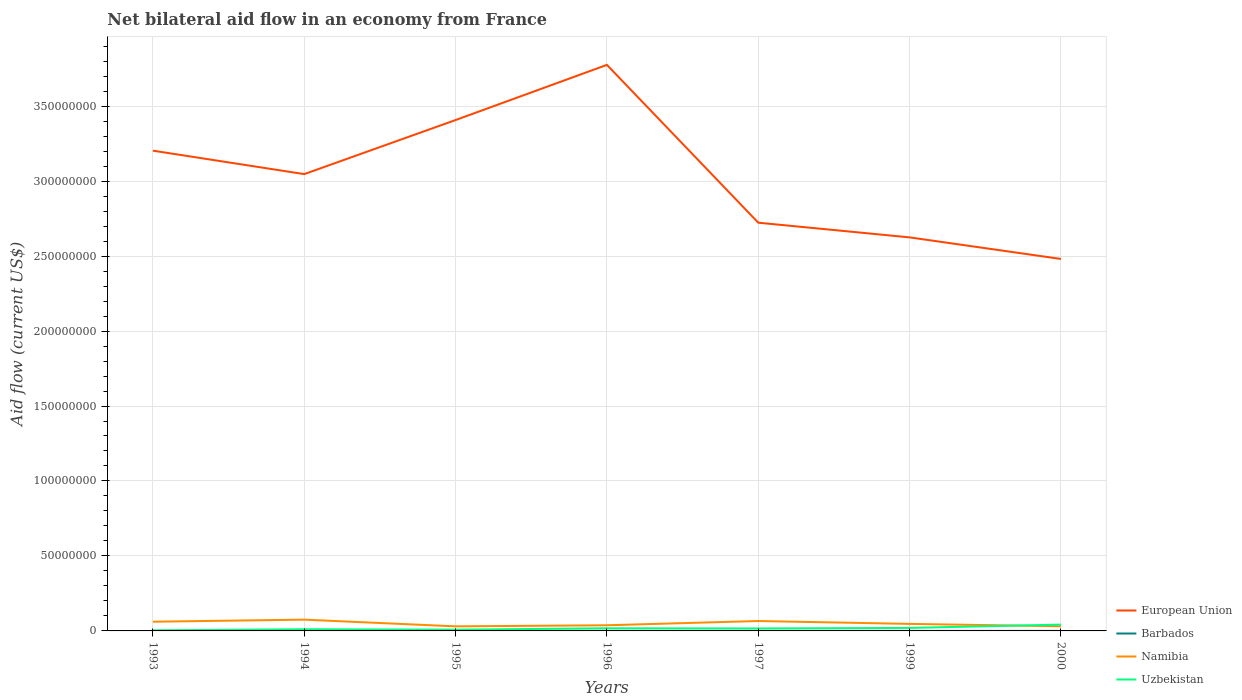How many different coloured lines are there?
Offer a very short reply. 4. Is the number of lines equal to the number of legend labels?
Provide a succinct answer. Yes. Across all years, what is the maximum net bilateral aid flow in Uzbekistan?
Offer a very short reply. 3.80e+05. What is the total net bilateral aid flow in Uzbekistan in the graph?
Offer a very short reply. -2.21e+06. What is the difference between the highest and the second highest net bilateral aid flow in Uzbekistan?
Offer a terse response. 3.83e+06. What is the difference between the highest and the lowest net bilateral aid flow in European Union?
Your answer should be very brief. 4. What is the difference between two consecutive major ticks on the Y-axis?
Your answer should be very brief. 5.00e+07. Are the values on the major ticks of Y-axis written in scientific E-notation?
Keep it short and to the point. No. Does the graph contain any zero values?
Your answer should be compact. No. Where does the legend appear in the graph?
Offer a terse response. Bottom right. What is the title of the graph?
Offer a very short reply. Net bilateral aid flow in an economy from France. Does "Korea (Democratic)" appear as one of the legend labels in the graph?
Your answer should be very brief. No. What is the label or title of the Y-axis?
Ensure brevity in your answer.  Aid flow (current US$). What is the Aid flow (current US$) of European Union in 1993?
Provide a short and direct response. 3.20e+08. What is the Aid flow (current US$) in Namibia in 1993?
Your response must be concise. 6.15e+06. What is the Aid flow (current US$) in Uzbekistan in 1993?
Provide a succinct answer. 3.80e+05. What is the Aid flow (current US$) in European Union in 1994?
Ensure brevity in your answer.  3.05e+08. What is the Aid flow (current US$) of Namibia in 1994?
Your response must be concise. 7.52e+06. What is the Aid flow (current US$) of Uzbekistan in 1994?
Keep it short and to the point. 1.11e+06. What is the Aid flow (current US$) in European Union in 1995?
Ensure brevity in your answer.  3.41e+08. What is the Aid flow (current US$) in Barbados in 1995?
Offer a very short reply. 3.00e+04. What is the Aid flow (current US$) in Namibia in 1995?
Provide a short and direct response. 3.04e+06. What is the Aid flow (current US$) of Uzbekistan in 1995?
Your response must be concise. 8.30e+05. What is the Aid flow (current US$) of European Union in 1996?
Provide a short and direct response. 3.78e+08. What is the Aid flow (current US$) of Namibia in 1996?
Give a very brief answer. 3.77e+06. What is the Aid flow (current US$) in Uzbekistan in 1996?
Give a very brief answer. 1.75e+06. What is the Aid flow (current US$) in European Union in 1997?
Make the answer very short. 2.72e+08. What is the Aid flow (current US$) of Namibia in 1997?
Keep it short and to the point. 6.61e+06. What is the Aid flow (current US$) of Uzbekistan in 1997?
Your response must be concise. 1.64e+06. What is the Aid flow (current US$) in European Union in 1999?
Provide a succinct answer. 2.62e+08. What is the Aid flow (current US$) of Namibia in 1999?
Offer a very short reply. 4.69e+06. What is the Aid flow (current US$) of European Union in 2000?
Your answer should be very brief. 2.48e+08. What is the Aid flow (current US$) of Barbados in 2000?
Keep it short and to the point. 10000. What is the Aid flow (current US$) of Namibia in 2000?
Ensure brevity in your answer.  3.12e+06. What is the Aid flow (current US$) of Uzbekistan in 2000?
Your response must be concise. 4.21e+06. Across all years, what is the maximum Aid flow (current US$) in European Union?
Provide a short and direct response. 3.78e+08. Across all years, what is the maximum Aid flow (current US$) in Barbados?
Keep it short and to the point. 5.00e+04. Across all years, what is the maximum Aid flow (current US$) in Namibia?
Offer a terse response. 7.52e+06. Across all years, what is the maximum Aid flow (current US$) of Uzbekistan?
Offer a terse response. 4.21e+06. Across all years, what is the minimum Aid flow (current US$) of European Union?
Offer a very short reply. 2.48e+08. Across all years, what is the minimum Aid flow (current US$) of Namibia?
Give a very brief answer. 3.04e+06. What is the total Aid flow (current US$) of European Union in the graph?
Keep it short and to the point. 2.13e+09. What is the total Aid flow (current US$) in Barbados in the graph?
Provide a succinct answer. 2.00e+05. What is the total Aid flow (current US$) of Namibia in the graph?
Offer a very short reply. 3.49e+07. What is the total Aid flow (current US$) in Uzbekistan in the graph?
Give a very brief answer. 1.19e+07. What is the difference between the Aid flow (current US$) in European Union in 1993 and that in 1994?
Offer a terse response. 1.56e+07. What is the difference between the Aid flow (current US$) in Namibia in 1993 and that in 1994?
Make the answer very short. -1.37e+06. What is the difference between the Aid flow (current US$) of Uzbekistan in 1993 and that in 1994?
Your answer should be compact. -7.30e+05. What is the difference between the Aid flow (current US$) in European Union in 1993 and that in 1995?
Your answer should be compact. -2.04e+07. What is the difference between the Aid flow (current US$) in Barbados in 1993 and that in 1995?
Make the answer very short. -2.00e+04. What is the difference between the Aid flow (current US$) in Namibia in 1993 and that in 1995?
Offer a very short reply. 3.11e+06. What is the difference between the Aid flow (current US$) of Uzbekistan in 1993 and that in 1995?
Give a very brief answer. -4.50e+05. What is the difference between the Aid flow (current US$) in European Union in 1993 and that in 1996?
Provide a short and direct response. -5.72e+07. What is the difference between the Aid flow (current US$) of Namibia in 1993 and that in 1996?
Ensure brevity in your answer.  2.38e+06. What is the difference between the Aid flow (current US$) in Uzbekistan in 1993 and that in 1996?
Ensure brevity in your answer.  -1.37e+06. What is the difference between the Aid flow (current US$) in European Union in 1993 and that in 1997?
Your response must be concise. 4.80e+07. What is the difference between the Aid flow (current US$) in Barbados in 1993 and that in 1997?
Provide a succinct answer. -3.00e+04. What is the difference between the Aid flow (current US$) of Namibia in 1993 and that in 1997?
Your answer should be very brief. -4.60e+05. What is the difference between the Aid flow (current US$) of Uzbekistan in 1993 and that in 1997?
Provide a short and direct response. -1.26e+06. What is the difference between the Aid flow (current US$) in European Union in 1993 and that in 1999?
Offer a very short reply. 5.78e+07. What is the difference between the Aid flow (current US$) in Namibia in 1993 and that in 1999?
Provide a short and direct response. 1.46e+06. What is the difference between the Aid flow (current US$) in Uzbekistan in 1993 and that in 1999?
Your answer should be compact. -1.62e+06. What is the difference between the Aid flow (current US$) in European Union in 1993 and that in 2000?
Give a very brief answer. 7.22e+07. What is the difference between the Aid flow (current US$) in Namibia in 1993 and that in 2000?
Your response must be concise. 3.03e+06. What is the difference between the Aid flow (current US$) in Uzbekistan in 1993 and that in 2000?
Keep it short and to the point. -3.83e+06. What is the difference between the Aid flow (current US$) of European Union in 1994 and that in 1995?
Your answer should be very brief. -3.61e+07. What is the difference between the Aid flow (current US$) in Namibia in 1994 and that in 1995?
Keep it short and to the point. 4.48e+06. What is the difference between the Aid flow (current US$) in European Union in 1994 and that in 1996?
Offer a terse response. -7.28e+07. What is the difference between the Aid flow (current US$) of Barbados in 1994 and that in 1996?
Keep it short and to the point. -2.00e+04. What is the difference between the Aid flow (current US$) in Namibia in 1994 and that in 1996?
Provide a short and direct response. 3.75e+06. What is the difference between the Aid flow (current US$) in Uzbekistan in 1994 and that in 1996?
Provide a short and direct response. -6.40e+05. What is the difference between the Aid flow (current US$) of European Union in 1994 and that in 1997?
Provide a short and direct response. 3.24e+07. What is the difference between the Aid flow (current US$) of Namibia in 1994 and that in 1997?
Your answer should be compact. 9.10e+05. What is the difference between the Aid flow (current US$) of Uzbekistan in 1994 and that in 1997?
Your response must be concise. -5.30e+05. What is the difference between the Aid flow (current US$) of European Union in 1994 and that in 1999?
Make the answer very short. 4.22e+07. What is the difference between the Aid flow (current US$) in Barbados in 1994 and that in 1999?
Provide a short and direct response. 0. What is the difference between the Aid flow (current US$) of Namibia in 1994 and that in 1999?
Give a very brief answer. 2.83e+06. What is the difference between the Aid flow (current US$) of Uzbekistan in 1994 and that in 1999?
Your answer should be very brief. -8.90e+05. What is the difference between the Aid flow (current US$) in European Union in 1994 and that in 2000?
Make the answer very short. 5.66e+07. What is the difference between the Aid flow (current US$) of Namibia in 1994 and that in 2000?
Provide a succinct answer. 4.40e+06. What is the difference between the Aid flow (current US$) of Uzbekistan in 1994 and that in 2000?
Provide a succinct answer. -3.10e+06. What is the difference between the Aid flow (current US$) of European Union in 1995 and that in 1996?
Ensure brevity in your answer.  -3.68e+07. What is the difference between the Aid flow (current US$) in Namibia in 1995 and that in 1996?
Offer a terse response. -7.30e+05. What is the difference between the Aid flow (current US$) of Uzbekistan in 1995 and that in 1996?
Make the answer very short. -9.20e+05. What is the difference between the Aid flow (current US$) in European Union in 1995 and that in 1997?
Provide a succinct answer. 6.85e+07. What is the difference between the Aid flow (current US$) in Namibia in 1995 and that in 1997?
Give a very brief answer. -3.57e+06. What is the difference between the Aid flow (current US$) in Uzbekistan in 1995 and that in 1997?
Ensure brevity in your answer.  -8.10e+05. What is the difference between the Aid flow (current US$) in European Union in 1995 and that in 1999?
Your answer should be compact. 7.83e+07. What is the difference between the Aid flow (current US$) in Namibia in 1995 and that in 1999?
Your answer should be very brief. -1.65e+06. What is the difference between the Aid flow (current US$) of Uzbekistan in 1995 and that in 1999?
Provide a succinct answer. -1.17e+06. What is the difference between the Aid flow (current US$) in European Union in 1995 and that in 2000?
Offer a terse response. 9.26e+07. What is the difference between the Aid flow (current US$) in Namibia in 1995 and that in 2000?
Your answer should be very brief. -8.00e+04. What is the difference between the Aid flow (current US$) in Uzbekistan in 1995 and that in 2000?
Provide a short and direct response. -3.38e+06. What is the difference between the Aid flow (current US$) of European Union in 1996 and that in 1997?
Your response must be concise. 1.05e+08. What is the difference between the Aid flow (current US$) in Barbados in 1996 and that in 1997?
Your answer should be compact. 10000. What is the difference between the Aid flow (current US$) in Namibia in 1996 and that in 1997?
Give a very brief answer. -2.84e+06. What is the difference between the Aid flow (current US$) of Uzbekistan in 1996 and that in 1997?
Ensure brevity in your answer.  1.10e+05. What is the difference between the Aid flow (current US$) of European Union in 1996 and that in 1999?
Offer a terse response. 1.15e+08. What is the difference between the Aid flow (current US$) in Namibia in 1996 and that in 1999?
Offer a terse response. -9.20e+05. What is the difference between the Aid flow (current US$) of Uzbekistan in 1996 and that in 1999?
Keep it short and to the point. -2.50e+05. What is the difference between the Aid flow (current US$) of European Union in 1996 and that in 2000?
Keep it short and to the point. 1.29e+08. What is the difference between the Aid flow (current US$) in Barbados in 1996 and that in 2000?
Your answer should be compact. 4.00e+04. What is the difference between the Aid flow (current US$) of Namibia in 1996 and that in 2000?
Provide a succinct answer. 6.50e+05. What is the difference between the Aid flow (current US$) of Uzbekistan in 1996 and that in 2000?
Offer a very short reply. -2.46e+06. What is the difference between the Aid flow (current US$) in European Union in 1997 and that in 1999?
Keep it short and to the point. 9.80e+06. What is the difference between the Aid flow (current US$) of Barbados in 1997 and that in 1999?
Keep it short and to the point. 10000. What is the difference between the Aid flow (current US$) in Namibia in 1997 and that in 1999?
Offer a terse response. 1.92e+06. What is the difference between the Aid flow (current US$) in Uzbekistan in 1997 and that in 1999?
Your response must be concise. -3.60e+05. What is the difference between the Aid flow (current US$) in European Union in 1997 and that in 2000?
Make the answer very short. 2.42e+07. What is the difference between the Aid flow (current US$) in Barbados in 1997 and that in 2000?
Your answer should be compact. 3.00e+04. What is the difference between the Aid flow (current US$) of Namibia in 1997 and that in 2000?
Provide a short and direct response. 3.49e+06. What is the difference between the Aid flow (current US$) of Uzbekistan in 1997 and that in 2000?
Your response must be concise. -2.57e+06. What is the difference between the Aid flow (current US$) of European Union in 1999 and that in 2000?
Your answer should be compact. 1.44e+07. What is the difference between the Aid flow (current US$) in Namibia in 1999 and that in 2000?
Offer a very short reply. 1.57e+06. What is the difference between the Aid flow (current US$) of Uzbekistan in 1999 and that in 2000?
Offer a very short reply. -2.21e+06. What is the difference between the Aid flow (current US$) in European Union in 1993 and the Aid flow (current US$) in Barbados in 1994?
Provide a short and direct response. 3.20e+08. What is the difference between the Aid flow (current US$) of European Union in 1993 and the Aid flow (current US$) of Namibia in 1994?
Ensure brevity in your answer.  3.13e+08. What is the difference between the Aid flow (current US$) of European Union in 1993 and the Aid flow (current US$) of Uzbekistan in 1994?
Provide a short and direct response. 3.19e+08. What is the difference between the Aid flow (current US$) of Barbados in 1993 and the Aid flow (current US$) of Namibia in 1994?
Your response must be concise. -7.51e+06. What is the difference between the Aid flow (current US$) of Barbados in 1993 and the Aid flow (current US$) of Uzbekistan in 1994?
Keep it short and to the point. -1.10e+06. What is the difference between the Aid flow (current US$) in Namibia in 1993 and the Aid flow (current US$) in Uzbekistan in 1994?
Ensure brevity in your answer.  5.04e+06. What is the difference between the Aid flow (current US$) in European Union in 1993 and the Aid flow (current US$) in Barbados in 1995?
Ensure brevity in your answer.  3.20e+08. What is the difference between the Aid flow (current US$) in European Union in 1993 and the Aid flow (current US$) in Namibia in 1995?
Provide a short and direct response. 3.17e+08. What is the difference between the Aid flow (current US$) in European Union in 1993 and the Aid flow (current US$) in Uzbekistan in 1995?
Keep it short and to the point. 3.19e+08. What is the difference between the Aid flow (current US$) of Barbados in 1993 and the Aid flow (current US$) of Namibia in 1995?
Provide a short and direct response. -3.03e+06. What is the difference between the Aid flow (current US$) of Barbados in 1993 and the Aid flow (current US$) of Uzbekistan in 1995?
Keep it short and to the point. -8.20e+05. What is the difference between the Aid flow (current US$) of Namibia in 1993 and the Aid flow (current US$) of Uzbekistan in 1995?
Your answer should be very brief. 5.32e+06. What is the difference between the Aid flow (current US$) in European Union in 1993 and the Aid flow (current US$) in Barbados in 1996?
Keep it short and to the point. 3.20e+08. What is the difference between the Aid flow (current US$) of European Union in 1993 and the Aid flow (current US$) of Namibia in 1996?
Offer a very short reply. 3.17e+08. What is the difference between the Aid flow (current US$) of European Union in 1993 and the Aid flow (current US$) of Uzbekistan in 1996?
Provide a short and direct response. 3.19e+08. What is the difference between the Aid flow (current US$) in Barbados in 1993 and the Aid flow (current US$) in Namibia in 1996?
Your answer should be very brief. -3.76e+06. What is the difference between the Aid flow (current US$) of Barbados in 1993 and the Aid flow (current US$) of Uzbekistan in 1996?
Your response must be concise. -1.74e+06. What is the difference between the Aid flow (current US$) in Namibia in 1993 and the Aid flow (current US$) in Uzbekistan in 1996?
Your answer should be compact. 4.40e+06. What is the difference between the Aid flow (current US$) of European Union in 1993 and the Aid flow (current US$) of Barbados in 1997?
Your answer should be compact. 3.20e+08. What is the difference between the Aid flow (current US$) in European Union in 1993 and the Aid flow (current US$) in Namibia in 1997?
Provide a short and direct response. 3.14e+08. What is the difference between the Aid flow (current US$) of European Union in 1993 and the Aid flow (current US$) of Uzbekistan in 1997?
Keep it short and to the point. 3.19e+08. What is the difference between the Aid flow (current US$) in Barbados in 1993 and the Aid flow (current US$) in Namibia in 1997?
Your response must be concise. -6.60e+06. What is the difference between the Aid flow (current US$) of Barbados in 1993 and the Aid flow (current US$) of Uzbekistan in 1997?
Provide a succinct answer. -1.63e+06. What is the difference between the Aid flow (current US$) of Namibia in 1993 and the Aid flow (current US$) of Uzbekistan in 1997?
Ensure brevity in your answer.  4.51e+06. What is the difference between the Aid flow (current US$) of European Union in 1993 and the Aid flow (current US$) of Barbados in 1999?
Your answer should be very brief. 3.20e+08. What is the difference between the Aid flow (current US$) in European Union in 1993 and the Aid flow (current US$) in Namibia in 1999?
Provide a succinct answer. 3.16e+08. What is the difference between the Aid flow (current US$) of European Union in 1993 and the Aid flow (current US$) of Uzbekistan in 1999?
Provide a succinct answer. 3.18e+08. What is the difference between the Aid flow (current US$) of Barbados in 1993 and the Aid flow (current US$) of Namibia in 1999?
Provide a succinct answer. -4.68e+06. What is the difference between the Aid flow (current US$) in Barbados in 1993 and the Aid flow (current US$) in Uzbekistan in 1999?
Make the answer very short. -1.99e+06. What is the difference between the Aid flow (current US$) of Namibia in 1993 and the Aid flow (current US$) of Uzbekistan in 1999?
Your response must be concise. 4.15e+06. What is the difference between the Aid flow (current US$) of European Union in 1993 and the Aid flow (current US$) of Barbados in 2000?
Offer a very short reply. 3.20e+08. What is the difference between the Aid flow (current US$) of European Union in 1993 and the Aid flow (current US$) of Namibia in 2000?
Keep it short and to the point. 3.17e+08. What is the difference between the Aid flow (current US$) in European Union in 1993 and the Aid flow (current US$) in Uzbekistan in 2000?
Make the answer very short. 3.16e+08. What is the difference between the Aid flow (current US$) in Barbados in 1993 and the Aid flow (current US$) in Namibia in 2000?
Make the answer very short. -3.11e+06. What is the difference between the Aid flow (current US$) of Barbados in 1993 and the Aid flow (current US$) of Uzbekistan in 2000?
Provide a succinct answer. -4.20e+06. What is the difference between the Aid flow (current US$) in Namibia in 1993 and the Aid flow (current US$) in Uzbekistan in 2000?
Your answer should be very brief. 1.94e+06. What is the difference between the Aid flow (current US$) of European Union in 1994 and the Aid flow (current US$) of Barbados in 1995?
Offer a terse response. 3.05e+08. What is the difference between the Aid flow (current US$) in European Union in 1994 and the Aid flow (current US$) in Namibia in 1995?
Provide a succinct answer. 3.02e+08. What is the difference between the Aid flow (current US$) in European Union in 1994 and the Aid flow (current US$) in Uzbekistan in 1995?
Your answer should be compact. 3.04e+08. What is the difference between the Aid flow (current US$) of Barbados in 1994 and the Aid flow (current US$) of Namibia in 1995?
Your answer should be compact. -3.01e+06. What is the difference between the Aid flow (current US$) in Barbados in 1994 and the Aid flow (current US$) in Uzbekistan in 1995?
Your answer should be very brief. -8.00e+05. What is the difference between the Aid flow (current US$) in Namibia in 1994 and the Aid flow (current US$) in Uzbekistan in 1995?
Offer a very short reply. 6.69e+06. What is the difference between the Aid flow (current US$) of European Union in 1994 and the Aid flow (current US$) of Barbados in 1996?
Give a very brief answer. 3.05e+08. What is the difference between the Aid flow (current US$) in European Union in 1994 and the Aid flow (current US$) in Namibia in 1996?
Make the answer very short. 3.01e+08. What is the difference between the Aid flow (current US$) of European Union in 1994 and the Aid flow (current US$) of Uzbekistan in 1996?
Your answer should be very brief. 3.03e+08. What is the difference between the Aid flow (current US$) of Barbados in 1994 and the Aid flow (current US$) of Namibia in 1996?
Give a very brief answer. -3.74e+06. What is the difference between the Aid flow (current US$) in Barbados in 1994 and the Aid flow (current US$) in Uzbekistan in 1996?
Provide a succinct answer. -1.72e+06. What is the difference between the Aid flow (current US$) of Namibia in 1994 and the Aid flow (current US$) of Uzbekistan in 1996?
Provide a succinct answer. 5.77e+06. What is the difference between the Aid flow (current US$) of European Union in 1994 and the Aid flow (current US$) of Barbados in 1997?
Offer a very short reply. 3.05e+08. What is the difference between the Aid flow (current US$) of European Union in 1994 and the Aid flow (current US$) of Namibia in 1997?
Provide a succinct answer. 2.98e+08. What is the difference between the Aid flow (current US$) of European Union in 1994 and the Aid flow (current US$) of Uzbekistan in 1997?
Give a very brief answer. 3.03e+08. What is the difference between the Aid flow (current US$) of Barbados in 1994 and the Aid flow (current US$) of Namibia in 1997?
Offer a terse response. -6.58e+06. What is the difference between the Aid flow (current US$) in Barbados in 1994 and the Aid flow (current US$) in Uzbekistan in 1997?
Offer a very short reply. -1.61e+06. What is the difference between the Aid flow (current US$) in Namibia in 1994 and the Aid flow (current US$) in Uzbekistan in 1997?
Provide a succinct answer. 5.88e+06. What is the difference between the Aid flow (current US$) in European Union in 1994 and the Aid flow (current US$) in Barbados in 1999?
Keep it short and to the point. 3.05e+08. What is the difference between the Aid flow (current US$) of European Union in 1994 and the Aid flow (current US$) of Namibia in 1999?
Keep it short and to the point. 3.00e+08. What is the difference between the Aid flow (current US$) in European Union in 1994 and the Aid flow (current US$) in Uzbekistan in 1999?
Your answer should be compact. 3.03e+08. What is the difference between the Aid flow (current US$) in Barbados in 1994 and the Aid flow (current US$) in Namibia in 1999?
Ensure brevity in your answer.  -4.66e+06. What is the difference between the Aid flow (current US$) of Barbados in 1994 and the Aid flow (current US$) of Uzbekistan in 1999?
Offer a terse response. -1.97e+06. What is the difference between the Aid flow (current US$) in Namibia in 1994 and the Aid flow (current US$) in Uzbekistan in 1999?
Provide a short and direct response. 5.52e+06. What is the difference between the Aid flow (current US$) of European Union in 1994 and the Aid flow (current US$) of Barbados in 2000?
Your answer should be very brief. 3.05e+08. What is the difference between the Aid flow (current US$) of European Union in 1994 and the Aid flow (current US$) of Namibia in 2000?
Offer a terse response. 3.02e+08. What is the difference between the Aid flow (current US$) of European Union in 1994 and the Aid flow (current US$) of Uzbekistan in 2000?
Your answer should be very brief. 3.00e+08. What is the difference between the Aid flow (current US$) of Barbados in 1994 and the Aid flow (current US$) of Namibia in 2000?
Your answer should be very brief. -3.09e+06. What is the difference between the Aid flow (current US$) in Barbados in 1994 and the Aid flow (current US$) in Uzbekistan in 2000?
Your response must be concise. -4.18e+06. What is the difference between the Aid flow (current US$) in Namibia in 1994 and the Aid flow (current US$) in Uzbekistan in 2000?
Your answer should be very brief. 3.31e+06. What is the difference between the Aid flow (current US$) of European Union in 1995 and the Aid flow (current US$) of Barbados in 1996?
Make the answer very short. 3.41e+08. What is the difference between the Aid flow (current US$) of European Union in 1995 and the Aid flow (current US$) of Namibia in 1996?
Make the answer very short. 3.37e+08. What is the difference between the Aid flow (current US$) of European Union in 1995 and the Aid flow (current US$) of Uzbekistan in 1996?
Offer a very short reply. 3.39e+08. What is the difference between the Aid flow (current US$) in Barbados in 1995 and the Aid flow (current US$) in Namibia in 1996?
Keep it short and to the point. -3.74e+06. What is the difference between the Aid flow (current US$) in Barbados in 1995 and the Aid flow (current US$) in Uzbekistan in 1996?
Offer a very short reply. -1.72e+06. What is the difference between the Aid flow (current US$) of Namibia in 1995 and the Aid flow (current US$) of Uzbekistan in 1996?
Offer a terse response. 1.29e+06. What is the difference between the Aid flow (current US$) in European Union in 1995 and the Aid flow (current US$) in Barbados in 1997?
Offer a terse response. 3.41e+08. What is the difference between the Aid flow (current US$) of European Union in 1995 and the Aid flow (current US$) of Namibia in 1997?
Your response must be concise. 3.34e+08. What is the difference between the Aid flow (current US$) of European Union in 1995 and the Aid flow (current US$) of Uzbekistan in 1997?
Ensure brevity in your answer.  3.39e+08. What is the difference between the Aid flow (current US$) of Barbados in 1995 and the Aid flow (current US$) of Namibia in 1997?
Ensure brevity in your answer.  -6.58e+06. What is the difference between the Aid flow (current US$) in Barbados in 1995 and the Aid flow (current US$) in Uzbekistan in 1997?
Provide a short and direct response. -1.61e+06. What is the difference between the Aid flow (current US$) of Namibia in 1995 and the Aid flow (current US$) of Uzbekistan in 1997?
Give a very brief answer. 1.40e+06. What is the difference between the Aid flow (current US$) of European Union in 1995 and the Aid flow (current US$) of Barbados in 1999?
Make the answer very short. 3.41e+08. What is the difference between the Aid flow (current US$) in European Union in 1995 and the Aid flow (current US$) in Namibia in 1999?
Your answer should be very brief. 3.36e+08. What is the difference between the Aid flow (current US$) of European Union in 1995 and the Aid flow (current US$) of Uzbekistan in 1999?
Your response must be concise. 3.39e+08. What is the difference between the Aid flow (current US$) in Barbados in 1995 and the Aid flow (current US$) in Namibia in 1999?
Offer a terse response. -4.66e+06. What is the difference between the Aid flow (current US$) in Barbados in 1995 and the Aid flow (current US$) in Uzbekistan in 1999?
Provide a short and direct response. -1.97e+06. What is the difference between the Aid flow (current US$) of Namibia in 1995 and the Aid flow (current US$) of Uzbekistan in 1999?
Make the answer very short. 1.04e+06. What is the difference between the Aid flow (current US$) in European Union in 1995 and the Aid flow (current US$) in Barbados in 2000?
Offer a very short reply. 3.41e+08. What is the difference between the Aid flow (current US$) in European Union in 1995 and the Aid flow (current US$) in Namibia in 2000?
Ensure brevity in your answer.  3.38e+08. What is the difference between the Aid flow (current US$) in European Union in 1995 and the Aid flow (current US$) in Uzbekistan in 2000?
Ensure brevity in your answer.  3.37e+08. What is the difference between the Aid flow (current US$) in Barbados in 1995 and the Aid flow (current US$) in Namibia in 2000?
Offer a terse response. -3.09e+06. What is the difference between the Aid flow (current US$) of Barbados in 1995 and the Aid flow (current US$) of Uzbekistan in 2000?
Give a very brief answer. -4.18e+06. What is the difference between the Aid flow (current US$) in Namibia in 1995 and the Aid flow (current US$) in Uzbekistan in 2000?
Your response must be concise. -1.17e+06. What is the difference between the Aid flow (current US$) of European Union in 1996 and the Aid flow (current US$) of Barbados in 1997?
Make the answer very short. 3.77e+08. What is the difference between the Aid flow (current US$) in European Union in 1996 and the Aid flow (current US$) in Namibia in 1997?
Offer a terse response. 3.71e+08. What is the difference between the Aid flow (current US$) in European Union in 1996 and the Aid flow (current US$) in Uzbekistan in 1997?
Your response must be concise. 3.76e+08. What is the difference between the Aid flow (current US$) in Barbados in 1996 and the Aid flow (current US$) in Namibia in 1997?
Your response must be concise. -6.56e+06. What is the difference between the Aid flow (current US$) of Barbados in 1996 and the Aid flow (current US$) of Uzbekistan in 1997?
Offer a very short reply. -1.59e+06. What is the difference between the Aid flow (current US$) of Namibia in 1996 and the Aid flow (current US$) of Uzbekistan in 1997?
Make the answer very short. 2.13e+06. What is the difference between the Aid flow (current US$) in European Union in 1996 and the Aid flow (current US$) in Barbados in 1999?
Ensure brevity in your answer.  3.77e+08. What is the difference between the Aid flow (current US$) in European Union in 1996 and the Aid flow (current US$) in Namibia in 1999?
Provide a succinct answer. 3.73e+08. What is the difference between the Aid flow (current US$) of European Union in 1996 and the Aid flow (current US$) of Uzbekistan in 1999?
Your response must be concise. 3.76e+08. What is the difference between the Aid flow (current US$) of Barbados in 1996 and the Aid flow (current US$) of Namibia in 1999?
Keep it short and to the point. -4.64e+06. What is the difference between the Aid flow (current US$) of Barbados in 1996 and the Aid flow (current US$) of Uzbekistan in 1999?
Provide a short and direct response. -1.95e+06. What is the difference between the Aid flow (current US$) of Namibia in 1996 and the Aid flow (current US$) of Uzbekistan in 1999?
Offer a terse response. 1.77e+06. What is the difference between the Aid flow (current US$) in European Union in 1996 and the Aid flow (current US$) in Barbados in 2000?
Provide a short and direct response. 3.78e+08. What is the difference between the Aid flow (current US$) of European Union in 1996 and the Aid flow (current US$) of Namibia in 2000?
Your answer should be very brief. 3.74e+08. What is the difference between the Aid flow (current US$) in European Union in 1996 and the Aid flow (current US$) in Uzbekistan in 2000?
Make the answer very short. 3.73e+08. What is the difference between the Aid flow (current US$) of Barbados in 1996 and the Aid flow (current US$) of Namibia in 2000?
Make the answer very short. -3.07e+06. What is the difference between the Aid flow (current US$) of Barbados in 1996 and the Aid flow (current US$) of Uzbekistan in 2000?
Give a very brief answer. -4.16e+06. What is the difference between the Aid flow (current US$) of Namibia in 1996 and the Aid flow (current US$) of Uzbekistan in 2000?
Your response must be concise. -4.40e+05. What is the difference between the Aid flow (current US$) of European Union in 1997 and the Aid flow (current US$) of Barbados in 1999?
Your response must be concise. 2.72e+08. What is the difference between the Aid flow (current US$) in European Union in 1997 and the Aid flow (current US$) in Namibia in 1999?
Your answer should be compact. 2.68e+08. What is the difference between the Aid flow (current US$) of European Union in 1997 and the Aid flow (current US$) of Uzbekistan in 1999?
Give a very brief answer. 2.70e+08. What is the difference between the Aid flow (current US$) in Barbados in 1997 and the Aid flow (current US$) in Namibia in 1999?
Ensure brevity in your answer.  -4.65e+06. What is the difference between the Aid flow (current US$) of Barbados in 1997 and the Aid flow (current US$) of Uzbekistan in 1999?
Ensure brevity in your answer.  -1.96e+06. What is the difference between the Aid flow (current US$) of Namibia in 1997 and the Aid flow (current US$) of Uzbekistan in 1999?
Your answer should be very brief. 4.61e+06. What is the difference between the Aid flow (current US$) of European Union in 1997 and the Aid flow (current US$) of Barbados in 2000?
Give a very brief answer. 2.72e+08. What is the difference between the Aid flow (current US$) of European Union in 1997 and the Aid flow (current US$) of Namibia in 2000?
Your answer should be compact. 2.69e+08. What is the difference between the Aid flow (current US$) of European Union in 1997 and the Aid flow (current US$) of Uzbekistan in 2000?
Your answer should be very brief. 2.68e+08. What is the difference between the Aid flow (current US$) of Barbados in 1997 and the Aid flow (current US$) of Namibia in 2000?
Ensure brevity in your answer.  -3.08e+06. What is the difference between the Aid flow (current US$) of Barbados in 1997 and the Aid flow (current US$) of Uzbekistan in 2000?
Provide a short and direct response. -4.17e+06. What is the difference between the Aid flow (current US$) in Namibia in 1997 and the Aid flow (current US$) in Uzbekistan in 2000?
Your answer should be very brief. 2.40e+06. What is the difference between the Aid flow (current US$) of European Union in 1999 and the Aid flow (current US$) of Barbados in 2000?
Your answer should be very brief. 2.62e+08. What is the difference between the Aid flow (current US$) of European Union in 1999 and the Aid flow (current US$) of Namibia in 2000?
Provide a succinct answer. 2.59e+08. What is the difference between the Aid flow (current US$) of European Union in 1999 and the Aid flow (current US$) of Uzbekistan in 2000?
Your response must be concise. 2.58e+08. What is the difference between the Aid flow (current US$) of Barbados in 1999 and the Aid flow (current US$) of Namibia in 2000?
Keep it short and to the point. -3.09e+06. What is the difference between the Aid flow (current US$) in Barbados in 1999 and the Aid flow (current US$) in Uzbekistan in 2000?
Give a very brief answer. -4.18e+06. What is the difference between the Aid flow (current US$) in Namibia in 1999 and the Aid flow (current US$) in Uzbekistan in 2000?
Provide a short and direct response. 4.80e+05. What is the average Aid flow (current US$) of European Union per year?
Your answer should be compact. 3.04e+08. What is the average Aid flow (current US$) in Barbados per year?
Your response must be concise. 2.86e+04. What is the average Aid flow (current US$) in Namibia per year?
Provide a succinct answer. 4.99e+06. What is the average Aid flow (current US$) in Uzbekistan per year?
Your response must be concise. 1.70e+06. In the year 1993, what is the difference between the Aid flow (current US$) of European Union and Aid flow (current US$) of Barbados?
Your response must be concise. 3.20e+08. In the year 1993, what is the difference between the Aid flow (current US$) in European Union and Aid flow (current US$) in Namibia?
Your answer should be very brief. 3.14e+08. In the year 1993, what is the difference between the Aid flow (current US$) of European Union and Aid flow (current US$) of Uzbekistan?
Your response must be concise. 3.20e+08. In the year 1993, what is the difference between the Aid flow (current US$) in Barbados and Aid flow (current US$) in Namibia?
Your answer should be compact. -6.14e+06. In the year 1993, what is the difference between the Aid flow (current US$) in Barbados and Aid flow (current US$) in Uzbekistan?
Make the answer very short. -3.70e+05. In the year 1993, what is the difference between the Aid flow (current US$) in Namibia and Aid flow (current US$) in Uzbekistan?
Your answer should be compact. 5.77e+06. In the year 1994, what is the difference between the Aid flow (current US$) of European Union and Aid flow (current US$) of Barbados?
Give a very brief answer. 3.05e+08. In the year 1994, what is the difference between the Aid flow (current US$) of European Union and Aid flow (current US$) of Namibia?
Your answer should be very brief. 2.97e+08. In the year 1994, what is the difference between the Aid flow (current US$) in European Union and Aid flow (current US$) in Uzbekistan?
Your answer should be compact. 3.04e+08. In the year 1994, what is the difference between the Aid flow (current US$) in Barbados and Aid flow (current US$) in Namibia?
Offer a very short reply. -7.49e+06. In the year 1994, what is the difference between the Aid flow (current US$) of Barbados and Aid flow (current US$) of Uzbekistan?
Your response must be concise. -1.08e+06. In the year 1994, what is the difference between the Aid flow (current US$) of Namibia and Aid flow (current US$) of Uzbekistan?
Ensure brevity in your answer.  6.41e+06. In the year 1995, what is the difference between the Aid flow (current US$) in European Union and Aid flow (current US$) in Barbados?
Offer a terse response. 3.41e+08. In the year 1995, what is the difference between the Aid flow (current US$) in European Union and Aid flow (current US$) in Namibia?
Make the answer very short. 3.38e+08. In the year 1995, what is the difference between the Aid flow (current US$) of European Union and Aid flow (current US$) of Uzbekistan?
Your answer should be very brief. 3.40e+08. In the year 1995, what is the difference between the Aid flow (current US$) in Barbados and Aid flow (current US$) in Namibia?
Offer a very short reply. -3.01e+06. In the year 1995, what is the difference between the Aid flow (current US$) in Barbados and Aid flow (current US$) in Uzbekistan?
Offer a terse response. -8.00e+05. In the year 1995, what is the difference between the Aid flow (current US$) of Namibia and Aid flow (current US$) of Uzbekistan?
Offer a very short reply. 2.21e+06. In the year 1996, what is the difference between the Aid flow (current US$) of European Union and Aid flow (current US$) of Barbados?
Your answer should be compact. 3.77e+08. In the year 1996, what is the difference between the Aid flow (current US$) of European Union and Aid flow (current US$) of Namibia?
Provide a short and direct response. 3.74e+08. In the year 1996, what is the difference between the Aid flow (current US$) of European Union and Aid flow (current US$) of Uzbekistan?
Your response must be concise. 3.76e+08. In the year 1996, what is the difference between the Aid flow (current US$) in Barbados and Aid flow (current US$) in Namibia?
Ensure brevity in your answer.  -3.72e+06. In the year 1996, what is the difference between the Aid flow (current US$) of Barbados and Aid flow (current US$) of Uzbekistan?
Make the answer very short. -1.70e+06. In the year 1996, what is the difference between the Aid flow (current US$) in Namibia and Aid flow (current US$) in Uzbekistan?
Ensure brevity in your answer.  2.02e+06. In the year 1997, what is the difference between the Aid flow (current US$) of European Union and Aid flow (current US$) of Barbados?
Your response must be concise. 2.72e+08. In the year 1997, what is the difference between the Aid flow (current US$) in European Union and Aid flow (current US$) in Namibia?
Give a very brief answer. 2.66e+08. In the year 1997, what is the difference between the Aid flow (current US$) of European Union and Aid flow (current US$) of Uzbekistan?
Your response must be concise. 2.71e+08. In the year 1997, what is the difference between the Aid flow (current US$) in Barbados and Aid flow (current US$) in Namibia?
Provide a succinct answer. -6.57e+06. In the year 1997, what is the difference between the Aid flow (current US$) in Barbados and Aid flow (current US$) in Uzbekistan?
Your answer should be compact. -1.60e+06. In the year 1997, what is the difference between the Aid flow (current US$) in Namibia and Aid flow (current US$) in Uzbekistan?
Keep it short and to the point. 4.97e+06. In the year 1999, what is the difference between the Aid flow (current US$) of European Union and Aid flow (current US$) of Barbados?
Your answer should be very brief. 2.62e+08. In the year 1999, what is the difference between the Aid flow (current US$) in European Union and Aid flow (current US$) in Namibia?
Keep it short and to the point. 2.58e+08. In the year 1999, what is the difference between the Aid flow (current US$) of European Union and Aid flow (current US$) of Uzbekistan?
Your answer should be compact. 2.60e+08. In the year 1999, what is the difference between the Aid flow (current US$) in Barbados and Aid flow (current US$) in Namibia?
Keep it short and to the point. -4.66e+06. In the year 1999, what is the difference between the Aid flow (current US$) in Barbados and Aid flow (current US$) in Uzbekistan?
Your answer should be very brief. -1.97e+06. In the year 1999, what is the difference between the Aid flow (current US$) of Namibia and Aid flow (current US$) of Uzbekistan?
Offer a very short reply. 2.69e+06. In the year 2000, what is the difference between the Aid flow (current US$) of European Union and Aid flow (current US$) of Barbados?
Offer a very short reply. 2.48e+08. In the year 2000, what is the difference between the Aid flow (current US$) in European Union and Aid flow (current US$) in Namibia?
Keep it short and to the point. 2.45e+08. In the year 2000, what is the difference between the Aid flow (current US$) of European Union and Aid flow (current US$) of Uzbekistan?
Your answer should be compact. 2.44e+08. In the year 2000, what is the difference between the Aid flow (current US$) of Barbados and Aid flow (current US$) of Namibia?
Offer a terse response. -3.11e+06. In the year 2000, what is the difference between the Aid flow (current US$) in Barbados and Aid flow (current US$) in Uzbekistan?
Your response must be concise. -4.20e+06. In the year 2000, what is the difference between the Aid flow (current US$) of Namibia and Aid flow (current US$) of Uzbekistan?
Your answer should be compact. -1.09e+06. What is the ratio of the Aid flow (current US$) of European Union in 1993 to that in 1994?
Your answer should be compact. 1.05. What is the ratio of the Aid flow (current US$) in Barbados in 1993 to that in 1994?
Offer a terse response. 0.33. What is the ratio of the Aid flow (current US$) of Namibia in 1993 to that in 1994?
Your answer should be very brief. 0.82. What is the ratio of the Aid flow (current US$) of Uzbekistan in 1993 to that in 1994?
Ensure brevity in your answer.  0.34. What is the ratio of the Aid flow (current US$) of European Union in 1993 to that in 1995?
Give a very brief answer. 0.94. What is the ratio of the Aid flow (current US$) in Namibia in 1993 to that in 1995?
Provide a succinct answer. 2.02. What is the ratio of the Aid flow (current US$) in Uzbekistan in 1993 to that in 1995?
Offer a terse response. 0.46. What is the ratio of the Aid flow (current US$) in European Union in 1993 to that in 1996?
Offer a terse response. 0.85. What is the ratio of the Aid flow (current US$) of Barbados in 1993 to that in 1996?
Your response must be concise. 0.2. What is the ratio of the Aid flow (current US$) in Namibia in 1993 to that in 1996?
Offer a terse response. 1.63. What is the ratio of the Aid flow (current US$) in Uzbekistan in 1993 to that in 1996?
Offer a very short reply. 0.22. What is the ratio of the Aid flow (current US$) of European Union in 1993 to that in 1997?
Ensure brevity in your answer.  1.18. What is the ratio of the Aid flow (current US$) in Namibia in 1993 to that in 1997?
Offer a terse response. 0.93. What is the ratio of the Aid flow (current US$) of Uzbekistan in 1993 to that in 1997?
Your response must be concise. 0.23. What is the ratio of the Aid flow (current US$) of European Union in 1993 to that in 1999?
Your answer should be compact. 1.22. What is the ratio of the Aid flow (current US$) in Barbados in 1993 to that in 1999?
Offer a very short reply. 0.33. What is the ratio of the Aid flow (current US$) of Namibia in 1993 to that in 1999?
Your answer should be compact. 1.31. What is the ratio of the Aid flow (current US$) in Uzbekistan in 1993 to that in 1999?
Your response must be concise. 0.19. What is the ratio of the Aid flow (current US$) of European Union in 1993 to that in 2000?
Ensure brevity in your answer.  1.29. What is the ratio of the Aid flow (current US$) of Namibia in 1993 to that in 2000?
Your answer should be very brief. 1.97. What is the ratio of the Aid flow (current US$) of Uzbekistan in 1993 to that in 2000?
Your response must be concise. 0.09. What is the ratio of the Aid flow (current US$) of European Union in 1994 to that in 1995?
Make the answer very short. 0.89. What is the ratio of the Aid flow (current US$) of Namibia in 1994 to that in 1995?
Make the answer very short. 2.47. What is the ratio of the Aid flow (current US$) in Uzbekistan in 1994 to that in 1995?
Give a very brief answer. 1.34. What is the ratio of the Aid flow (current US$) in European Union in 1994 to that in 1996?
Keep it short and to the point. 0.81. What is the ratio of the Aid flow (current US$) of Namibia in 1994 to that in 1996?
Ensure brevity in your answer.  1.99. What is the ratio of the Aid flow (current US$) of Uzbekistan in 1994 to that in 1996?
Keep it short and to the point. 0.63. What is the ratio of the Aid flow (current US$) in European Union in 1994 to that in 1997?
Offer a very short reply. 1.12. What is the ratio of the Aid flow (current US$) in Barbados in 1994 to that in 1997?
Ensure brevity in your answer.  0.75. What is the ratio of the Aid flow (current US$) of Namibia in 1994 to that in 1997?
Provide a short and direct response. 1.14. What is the ratio of the Aid flow (current US$) in Uzbekistan in 1994 to that in 1997?
Ensure brevity in your answer.  0.68. What is the ratio of the Aid flow (current US$) of European Union in 1994 to that in 1999?
Offer a very short reply. 1.16. What is the ratio of the Aid flow (current US$) in Barbados in 1994 to that in 1999?
Your answer should be very brief. 1. What is the ratio of the Aid flow (current US$) of Namibia in 1994 to that in 1999?
Give a very brief answer. 1.6. What is the ratio of the Aid flow (current US$) in Uzbekistan in 1994 to that in 1999?
Offer a terse response. 0.56. What is the ratio of the Aid flow (current US$) in European Union in 1994 to that in 2000?
Make the answer very short. 1.23. What is the ratio of the Aid flow (current US$) in Barbados in 1994 to that in 2000?
Keep it short and to the point. 3. What is the ratio of the Aid flow (current US$) of Namibia in 1994 to that in 2000?
Your answer should be very brief. 2.41. What is the ratio of the Aid flow (current US$) of Uzbekistan in 1994 to that in 2000?
Your answer should be very brief. 0.26. What is the ratio of the Aid flow (current US$) of European Union in 1995 to that in 1996?
Your answer should be very brief. 0.9. What is the ratio of the Aid flow (current US$) in Namibia in 1995 to that in 1996?
Make the answer very short. 0.81. What is the ratio of the Aid flow (current US$) in Uzbekistan in 1995 to that in 1996?
Offer a very short reply. 0.47. What is the ratio of the Aid flow (current US$) of European Union in 1995 to that in 1997?
Give a very brief answer. 1.25. What is the ratio of the Aid flow (current US$) in Namibia in 1995 to that in 1997?
Your response must be concise. 0.46. What is the ratio of the Aid flow (current US$) of Uzbekistan in 1995 to that in 1997?
Provide a short and direct response. 0.51. What is the ratio of the Aid flow (current US$) of European Union in 1995 to that in 1999?
Your answer should be compact. 1.3. What is the ratio of the Aid flow (current US$) of Barbados in 1995 to that in 1999?
Provide a succinct answer. 1. What is the ratio of the Aid flow (current US$) in Namibia in 1995 to that in 1999?
Your answer should be compact. 0.65. What is the ratio of the Aid flow (current US$) in Uzbekistan in 1995 to that in 1999?
Provide a short and direct response. 0.41. What is the ratio of the Aid flow (current US$) in European Union in 1995 to that in 2000?
Provide a succinct answer. 1.37. What is the ratio of the Aid flow (current US$) of Barbados in 1995 to that in 2000?
Offer a terse response. 3. What is the ratio of the Aid flow (current US$) in Namibia in 1995 to that in 2000?
Make the answer very short. 0.97. What is the ratio of the Aid flow (current US$) in Uzbekistan in 1995 to that in 2000?
Give a very brief answer. 0.2. What is the ratio of the Aid flow (current US$) in European Union in 1996 to that in 1997?
Provide a succinct answer. 1.39. What is the ratio of the Aid flow (current US$) of Barbados in 1996 to that in 1997?
Your response must be concise. 1.25. What is the ratio of the Aid flow (current US$) of Namibia in 1996 to that in 1997?
Your answer should be very brief. 0.57. What is the ratio of the Aid flow (current US$) in Uzbekistan in 1996 to that in 1997?
Make the answer very short. 1.07. What is the ratio of the Aid flow (current US$) in European Union in 1996 to that in 1999?
Your response must be concise. 1.44. What is the ratio of the Aid flow (current US$) in Barbados in 1996 to that in 1999?
Keep it short and to the point. 1.67. What is the ratio of the Aid flow (current US$) in Namibia in 1996 to that in 1999?
Give a very brief answer. 0.8. What is the ratio of the Aid flow (current US$) in Uzbekistan in 1996 to that in 1999?
Ensure brevity in your answer.  0.88. What is the ratio of the Aid flow (current US$) in European Union in 1996 to that in 2000?
Offer a terse response. 1.52. What is the ratio of the Aid flow (current US$) of Barbados in 1996 to that in 2000?
Keep it short and to the point. 5. What is the ratio of the Aid flow (current US$) in Namibia in 1996 to that in 2000?
Offer a terse response. 1.21. What is the ratio of the Aid flow (current US$) of Uzbekistan in 1996 to that in 2000?
Your answer should be compact. 0.42. What is the ratio of the Aid flow (current US$) in European Union in 1997 to that in 1999?
Your answer should be compact. 1.04. What is the ratio of the Aid flow (current US$) of Namibia in 1997 to that in 1999?
Offer a very short reply. 1.41. What is the ratio of the Aid flow (current US$) in Uzbekistan in 1997 to that in 1999?
Offer a very short reply. 0.82. What is the ratio of the Aid flow (current US$) of European Union in 1997 to that in 2000?
Make the answer very short. 1.1. What is the ratio of the Aid flow (current US$) in Namibia in 1997 to that in 2000?
Your answer should be compact. 2.12. What is the ratio of the Aid flow (current US$) in Uzbekistan in 1997 to that in 2000?
Keep it short and to the point. 0.39. What is the ratio of the Aid flow (current US$) of European Union in 1999 to that in 2000?
Keep it short and to the point. 1.06. What is the ratio of the Aid flow (current US$) of Barbados in 1999 to that in 2000?
Provide a succinct answer. 3. What is the ratio of the Aid flow (current US$) of Namibia in 1999 to that in 2000?
Offer a very short reply. 1.5. What is the ratio of the Aid flow (current US$) in Uzbekistan in 1999 to that in 2000?
Ensure brevity in your answer.  0.48. What is the difference between the highest and the second highest Aid flow (current US$) in European Union?
Give a very brief answer. 3.68e+07. What is the difference between the highest and the second highest Aid flow (current US$) in Namibia?
Your response must be concise. 9.10e+05. What is the difference between the highest and the second highest Aid flow (current US$) of Uzbekistan?
Your answer should be very brief. 2.21e+06. What is the difference between the highest and the lowest Aid flow (current US$) of European Union?
Your answer should be very brief. 1.29e+08. What is the difference between the highest and the lowest Aid flow (current US$) of Barbados?
Make the answer very short. 4.00e+04. What is the difference between the highest and the lowest Aid flow (current US$) in Namibia?
Provide a short and direct response. 4.48e+06. What is the difference between the highest and the lowest Aid flow (current US$) of Uzbekistan?
Offer a terse response. 3.83e+06. 